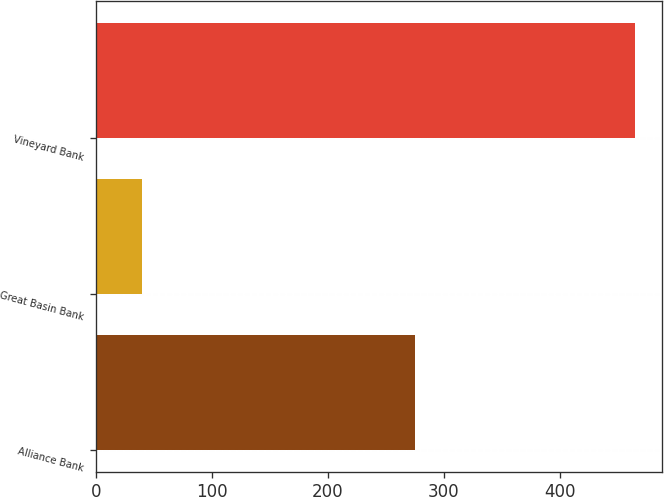Convert chart. <chart><loc_0><loc_0><loc_500><loc_500><bar_chart><fcel>Alliance Bank<fcel>Great Basin Bank<fcel>Vineyard Bank<nl><fcel>275<fcel>40<fcel>465<nl></chart> 